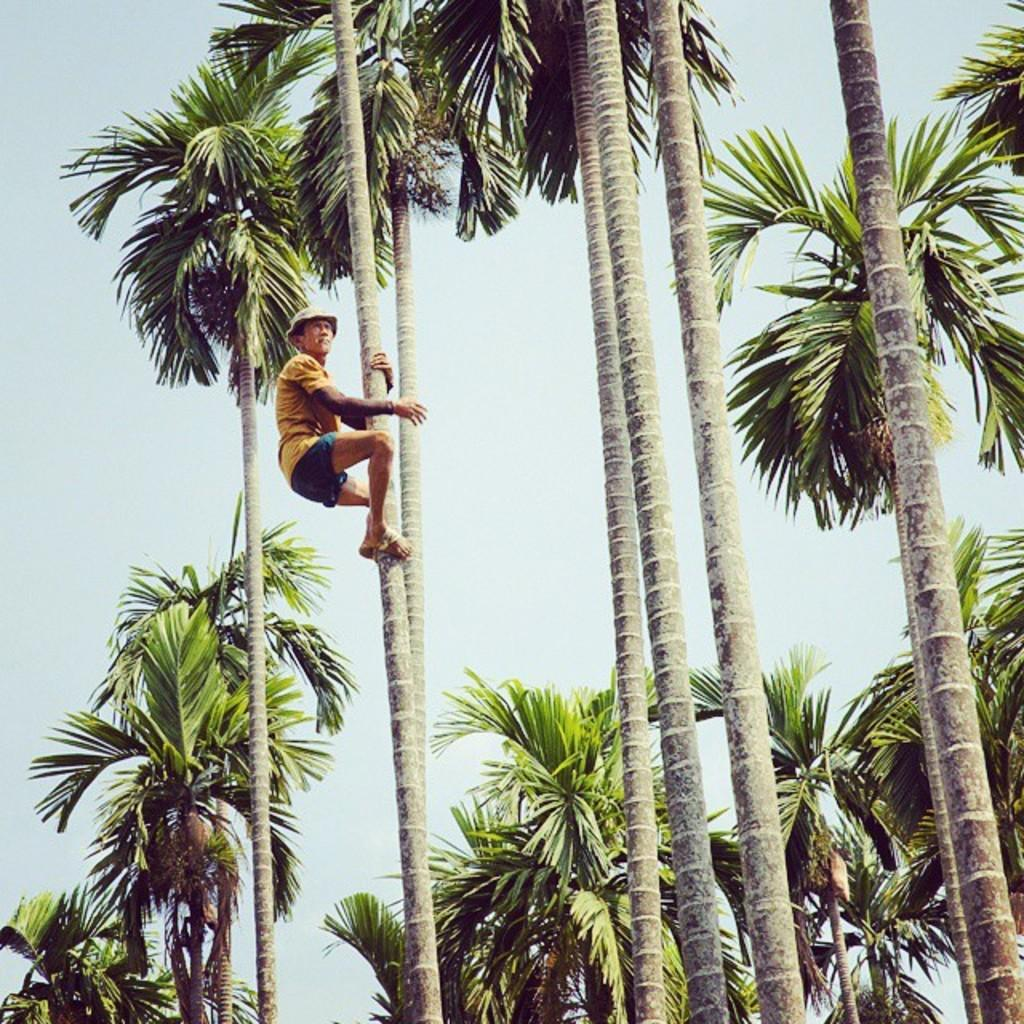Who is present in the image? There is a man in the image. What is the man doing in the image? The man is on a tree in the image. What can be seen in the background of the image? There are trees and the sky visible in the background of the image. What type of powder is being used by the man on the sofa in the image? There is no sofa or powder present in the image; it features a man on a tree. 